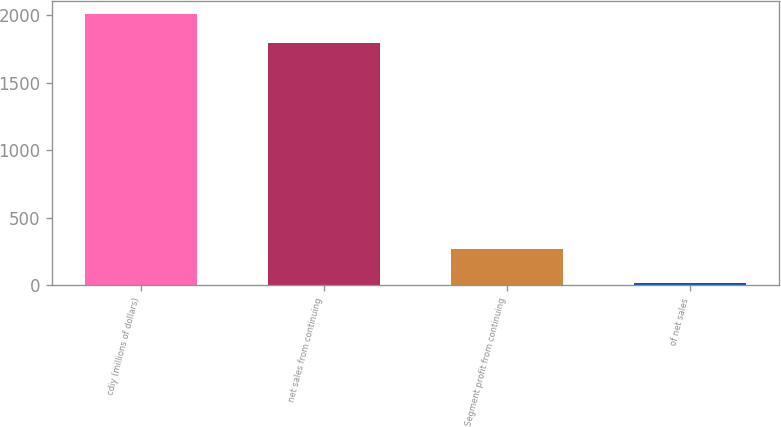Convert chart. <chart><loc_0><loc_0><loc_500><loc_500><bar_chart><fcel>cdiy (millions of dollars)<fcel>net sales from continuing<fcel>Segment profit from continuing<fcel>of net sales<nl><fcel>2007<fcel>1795<fcel>270<fcel>15<nl></chart> 